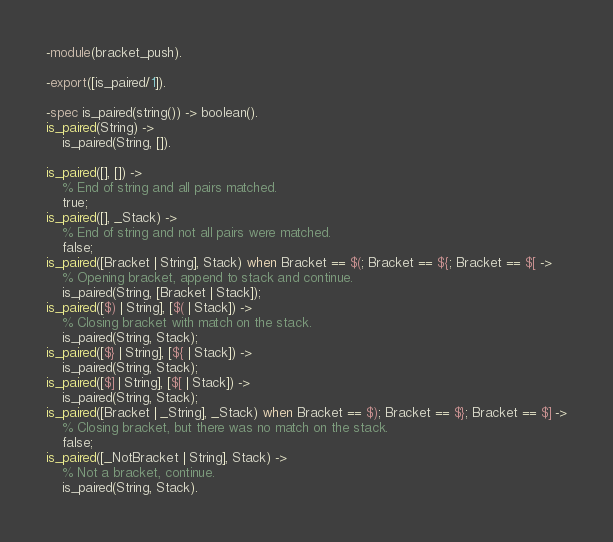Convert code to text. <code><loc_0><loc_0><loc_500><loc_500><_Erlang_>-module(bracket_push).

-export([is_paired/1]).

-spec is_paired(string()) -> boolean().
is_paired(String) ->
    is_paired(String, []).

is_paired([], []) ->
    % End of string and all pairs matched.
    true;
is_paired([], _Stack) ->
    % End of string and not all pairs were matched.
    false;
is_paired([Bracket | String], Stack) when Bracket == $(; Bracket == ${; Bracket == $[ ->
    % Opening bracket, append to stack and continue.
    is_paired(String, [Bracket | Stack]);
is_paired([$) | String], [$( | Stack]) ->
    % Closing bracket with match on the stack.
    is_paired(String, Stack);
is_paired([$} | String], [${ | Stack]) ->
    is_paired(String, Stack);
is_paired([$] | String], [$[ | Stack]) ->
    is_paired(String, Stack);
is_paired([Bracket | _String], _Stack) when Bracket == $); Bracket == $}; Bracket == $] ->
    % Closing bracket, but there was no match on the stack.
    false;
is_paired([_NotBracket | String], Stack) ->
    % Not a bracket, continue.
    is_paired(String, Stack).
</code> 